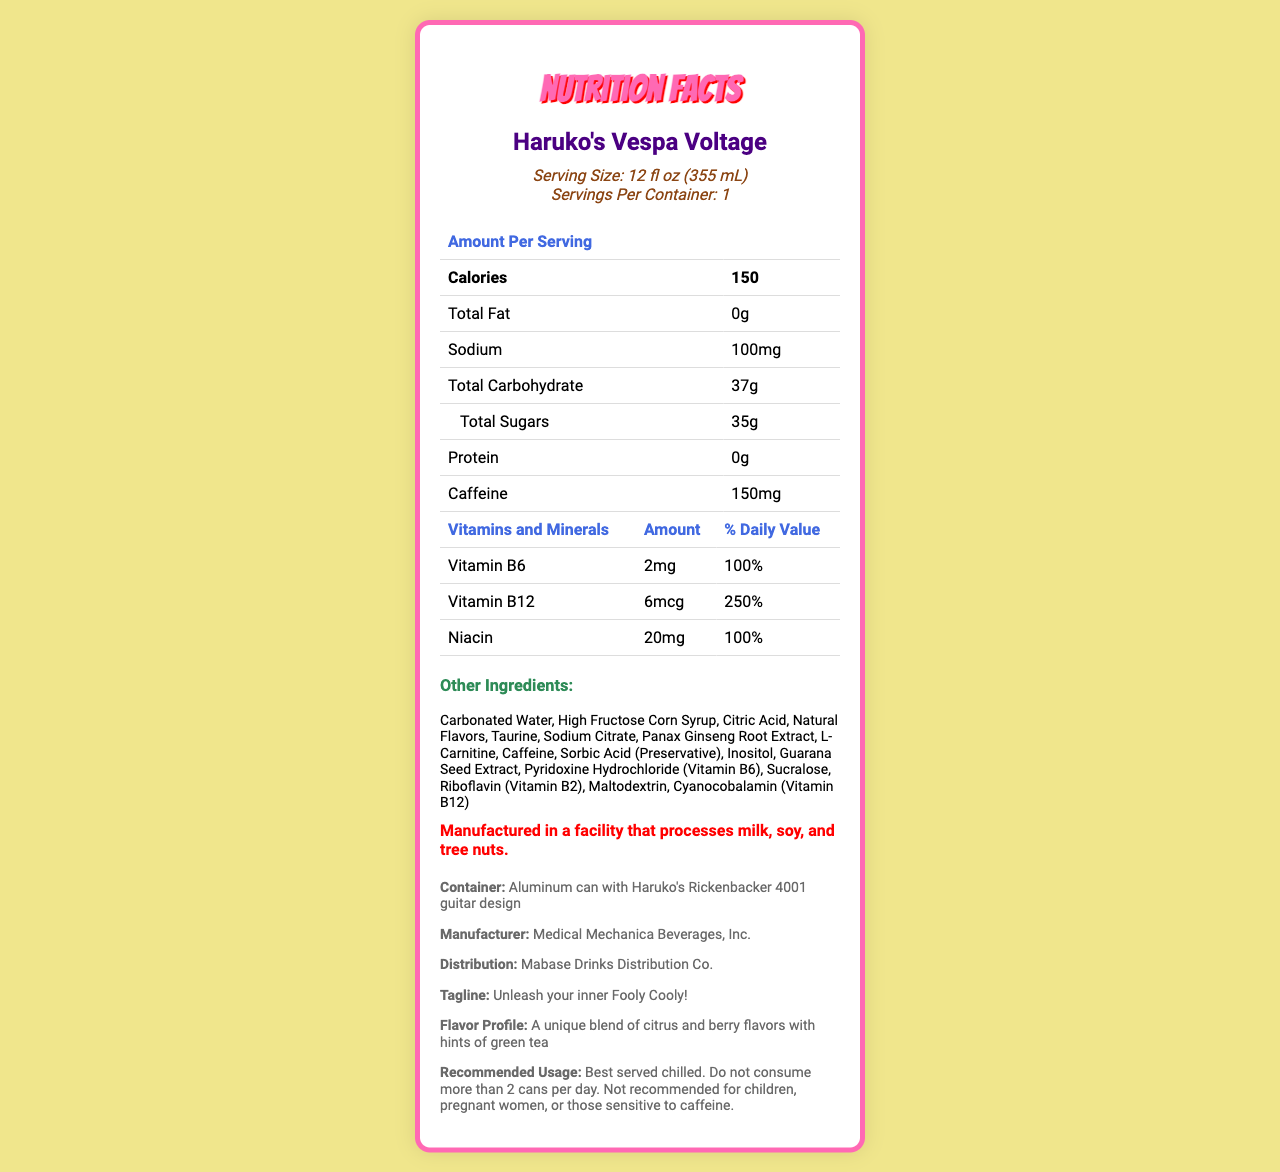What is the serving size of Haruko's Vespa Voltage? The serving size is clearly listed in the document as "12 fl oz (355 mL)".
Answer: 12 fl oz (355 mL) How much caffeine is in one serving? The document states that one serving contains 150mg of caffeine.
Answer: 150mg Name two vitamins present in Haruko's Vespa Voltage. The vitamins listed under "Vitamins and Minerals" include Vitamin B6 and Vitamin B12.
Answer: Vitamin B6 and Vitamin B12 What is the flavor profile of the drink? The flavor profile is described in the additional information section of the document.
Answer: A unique blend of citrus and berry flavors with hints of green tea List two ingredients found in Haruko's Vespa Voltage. The ingredients section lists several ingredients, including Carbonated Water and High Fructose Corn Syrup.
Answer: Carbonated Water, High Fructose Corn Syrup Where is the drink manufactured? A. USA B. Medical Mechanica Beverages, Inc. C. Mabase Drinks Distribution Co. The document specifies that the drink is manufactured by Medical Mechanica Beverages, Inc.
Answer: B Which of the following has the highest daily value percentage? I. Vitamin B6 II. Vitamin B12 III. Niacin Vitamin B12 has the highest daily value percentage at 250%, compared to 100% for both Vitamin B6 and Niacin.
Answer: II Is Haruko's Vespa Voltage recommended for children? The recommended usage section specifically states that it is not recommended for children.
Answer: No Summarize the main idea of the document. The document focuses on presenting comprehensive nutritional facts and additional product details for Haruko's Vespa Voltage.
Answer: The document provides detailed nutritional information about Haruko's Vespa Voltage, an FLCL-themed energy drink with Haruko's guitar design. It includes serving size, calories, fat, sodium, carbohydrates, sugars, protein, caffeine content, vitamins and minerals, other ingredients, allergen information, as well as additional marketing and usage details. What is the total amount of fat in Haruko's Vespa Voltage? The document clearly lists the total fat content as "0g".
Answer: 0g How many total sugars are present in the drink? The total sugars in the drink are listed as "35g".
Answer: 35g What facility process allergens are mentioned? The allergen information section mentions that the facility processes milk, soy, and tree nuts.
Answer: Milk, soy, and tree nuts How many servings are in one container of Haruko's Vespa Voltage? The serving information states that there is 1 serving per container.
Answer: 1 What is the daily value percentage for Niacin? The document section for vitamins and minerals specifies that Niacin provides 100% of the daily value.
Answer: 100% Can the name of the graphic designer who designed the can be determined from this document? The document provides product details and nutritional information but does not mention the designer of the can.
Answer: Not enough information 